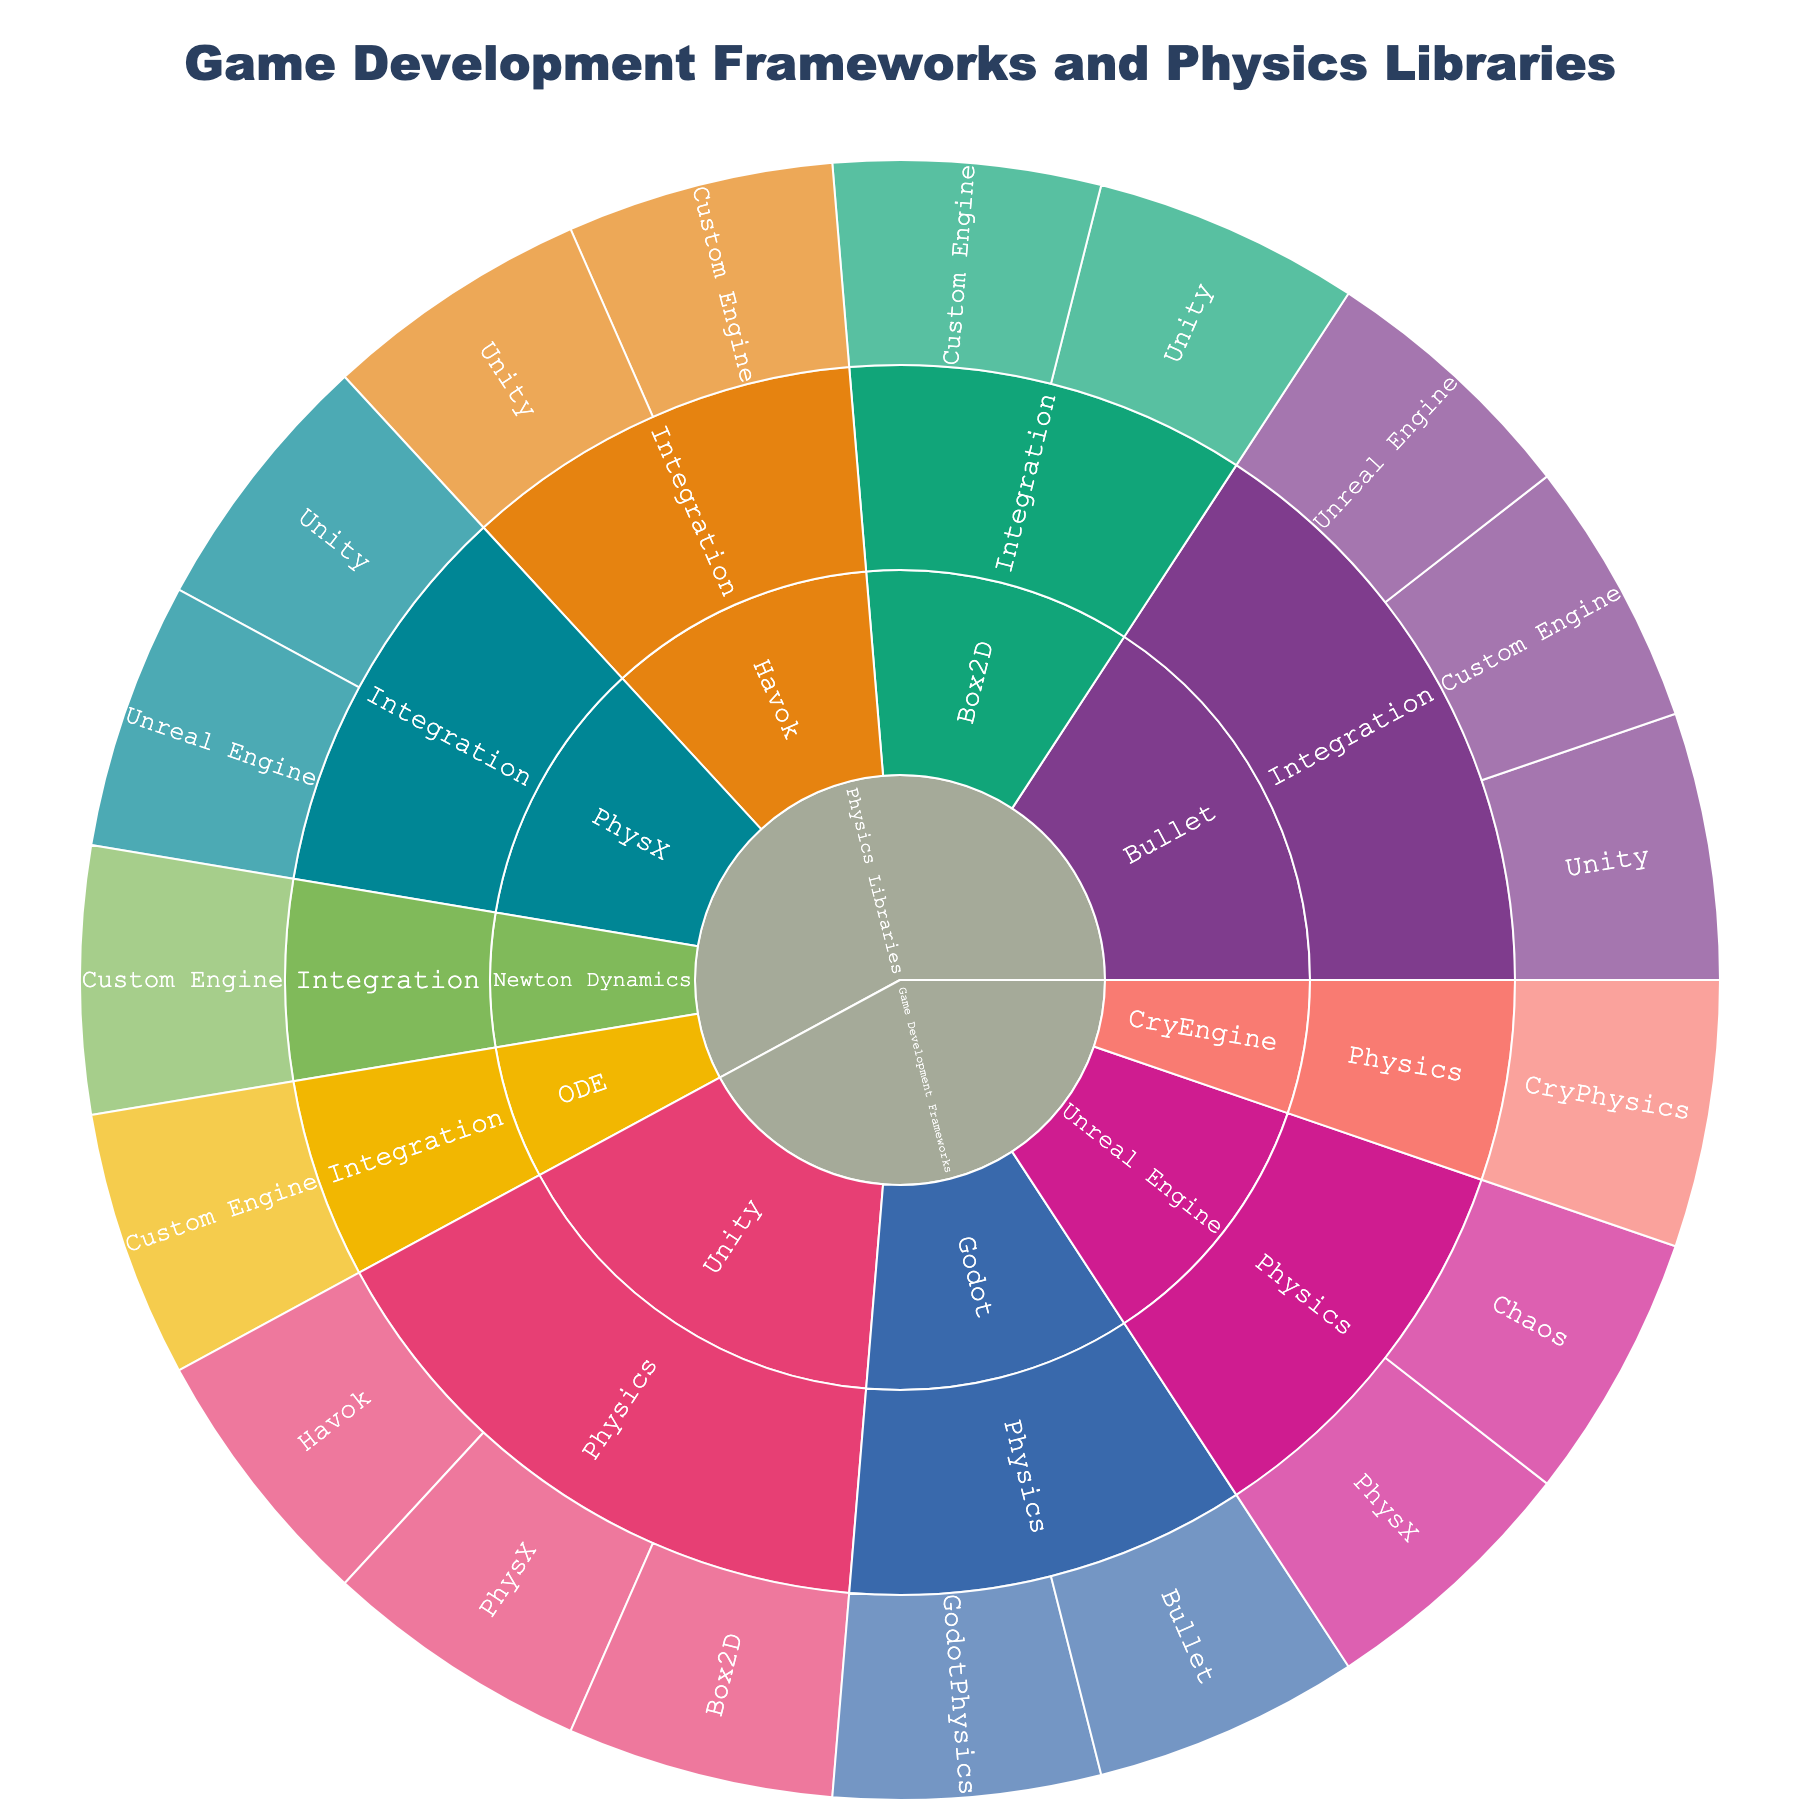What is the title of the Sunburst Plot? The title of a Sunburst Plot is usually displayed prominently at the top of the figure. To find the title, look at the text in the largest font size, usually centered. In this case, the title would reflect the content being visualized.
Answer: Game Development Frameworks and Physics Libraries Which game development framework is linked with the most physics engines? The outermost ring of the Sunburst Plot shows the distribution of items within each category. To determine which framework has the most physics engines, count the number of segments branching from each framework.
Answer: Unity How many physics libraries have integration with Unreal Engine? Locate the 'Physics Libraries' root category and navigate to the 'Integration' subcategory. Count how many times 'Unreal Engine' appears in the outer ring segments connected to different libraries.
Answer: 2 Which physics engine is integrated with the most game development frameworks? Look at the segments labeled under 'Physics Libraries' and their subsequent 'Integration' sub-segments. Identify which physics engine segment branches into the most framework sub-segments.
Answer: PhysX Are there any physics engines exclusive to the Godot framework? Under the 'Game Development Frameworks' root category, navigate to 'Godot' and inspect the physics engines linked to it. Check if any of these engines do not appear under other frameworks.
Answer: Yes, GodotPhysics How many unique physics engines are integrated across all game development frameworks? Under the 'Physics' subcategory of each framework, count each distinct physics engine mentioned.
Answer: 7 Which framework integrates the PhysX physics library? Under 'Physics Libraries', locate 'PhysX' and follow its branching into the 'Integration' subcategory to see which frameworks are listed.
Answer: Unity, Unreal Engine Compare the number of physics libraries integrated with Unity versus Unreal Engine. Which one has more? Under the 'Physics Libraries' root category, count the number of 'Integration' occurrences for 'Unity' and 'Unreal Engine'. Compare the two counts.
Answer: Unity has more Do any physics libraries integrate exclusively with custom game engines? Under the 'Physics Libraries' root category, navigate through each library’s 'Integration' subcategory and check if any libraries only list 'Custom Engine' and no other frameworks.
Answer: Yes Are there more physics engines or more game development frameworks in the plot? Sum the number of unique physics engines listed under each framework and compare it to the total number of game development frameworks listed directly.
Answer: More physics engines 